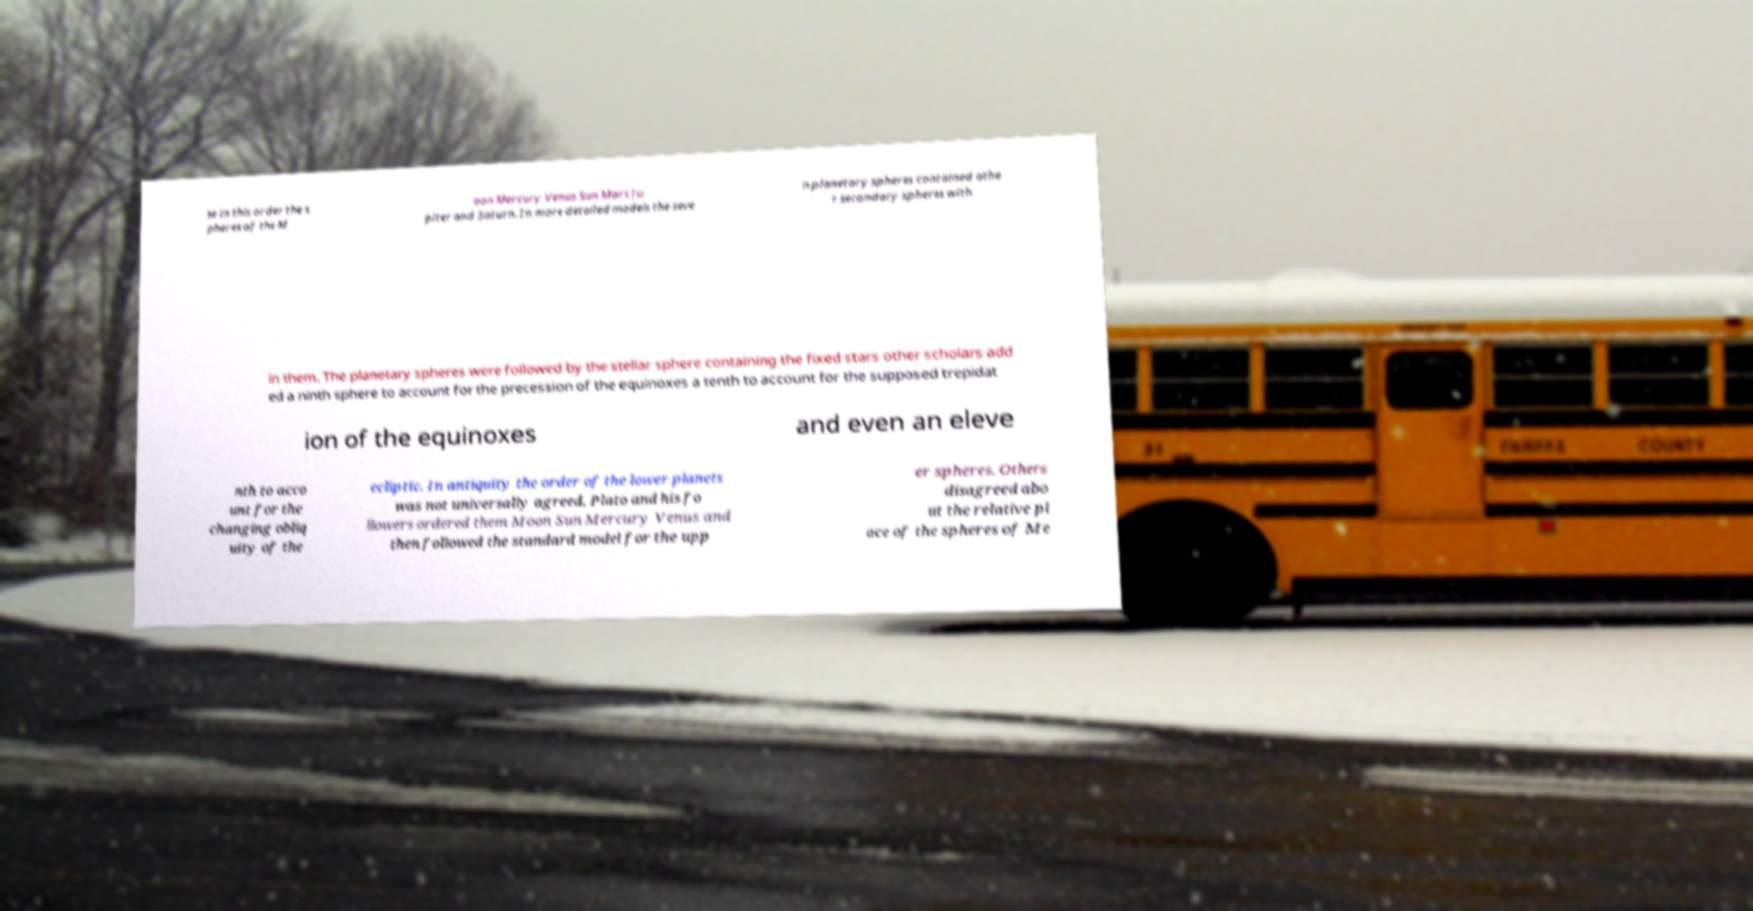Please read and relay the text visible in this image. What does it say? se in this order the s pheres of the M oon Mercury Venus Sun Mars Ju piter and Saturn. In more detailed models the seve n planetary spheres contained othe r secondary spheres with in them. The planetary spheres were followed by the stellar sphere containing the fixed stars other scholars add ed a ninth sphere to account for the precession of the equinoxes a tenth to account for the supposed trepidat ion of the equinoxes and even an eleve nth to acco unt for the changing obliq uity of the ecliptic. In antiquity the order of the lower planets was not universally agreed. Plato and his fo llowers ordered them Moon Sun Mercury Venus and then followed the standard model for the upp er spheres. Others disagreed abo ut the relative pl ace of the spheres of Me 